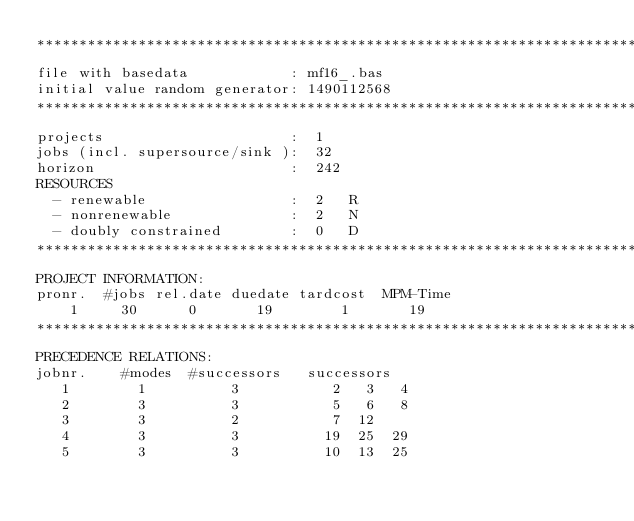<code> <loc_0><loc_0><loc_500><loc_500><_ObjectiveC_>************************************************************************
file with basedata            : mf16_.bas
initial value random generator: 1490112568
************************************************************************
projects                      :  1
jobs (incl. supersource/sink ):  32
horizon                       :  242
RESOURCES
  - renewable                 :  2   R
  - nonrenewable              :  2   N
  - doubly constrained        :  0   D
************************************************************************
PROJECT INFORMATION:
pronr.  #jobs rel.date duedate tardcost  MPM-Time
    1     30      0       19        1       19
************************************************************************
PRECEDENCE RELATIONS:
jobnr.    #modes  #successors   successors
   1        1          3           2   3   4
   2        3          3           5   6   8
   3        3          2           7  12
   4        3          3          19  25  29
   5        3          3          10  13  25</code> 